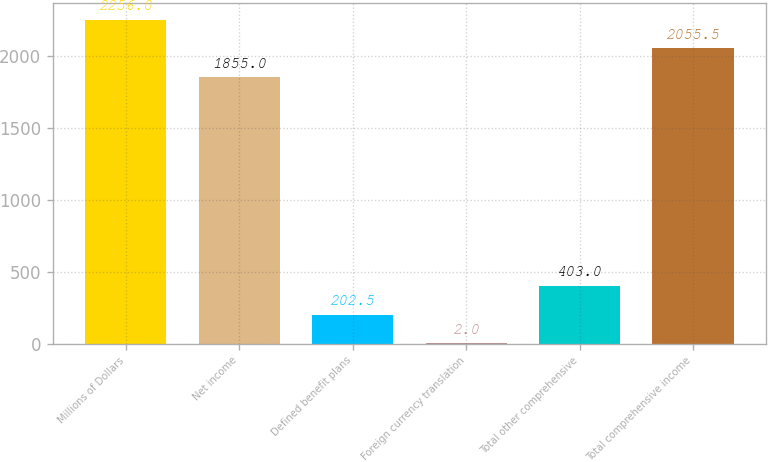Convert chart to OTSL. <chart><loc_0><loc_0><loc_500><loc_500><bar_chart><fcel>Millions of Dollars<fcel>Net income<fcel>Defined benefit plans<fcel>Foreign currency translation<fcel>Total other comprehensive<fcel>Total comprehensive income<nl><fcel>2256<fcel>1855<fcel>202.5<fcel>2<fcel>403<fcel>2055.5<nl></chart> 